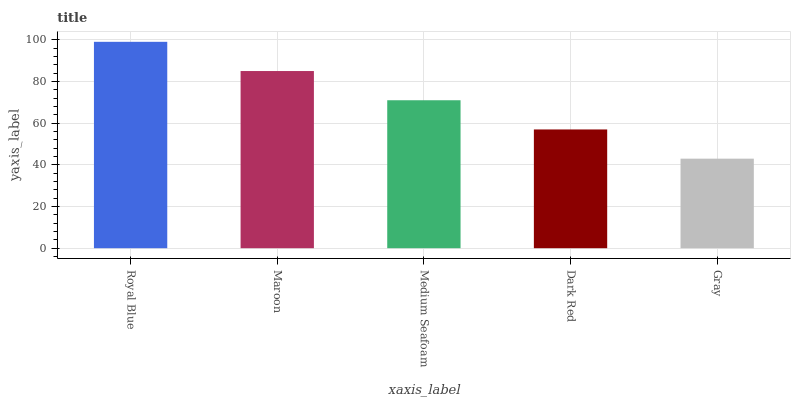Is Gray the minimum?
Answer yes or no. Yes. Is Royal Blue the maximum?
Answer yes or no. Yes. Is Maroon the minimum?
Answer yes or no. No. Is Maroon the maximum?
Answer yes or no. No. Is Royal Blue greater than Maroon?
Answer yes or no. Yes. Is Maroon less than Royal Blue?
Answer yes or no. Yes. Is Maroon greater than Royal Blue?
Answer yes or no. No. Is Royal Blue less than Maroon?
Answer yes or no. No. Is Medium Seafoam the high median?
Answer yes or no. Yes. Is Medium Seafoam the low median?
Answer yes or no. Yes. Is Gray the high median?
Answer yes or no. No. Is Gray the low median?
Answer yes or no. No. 